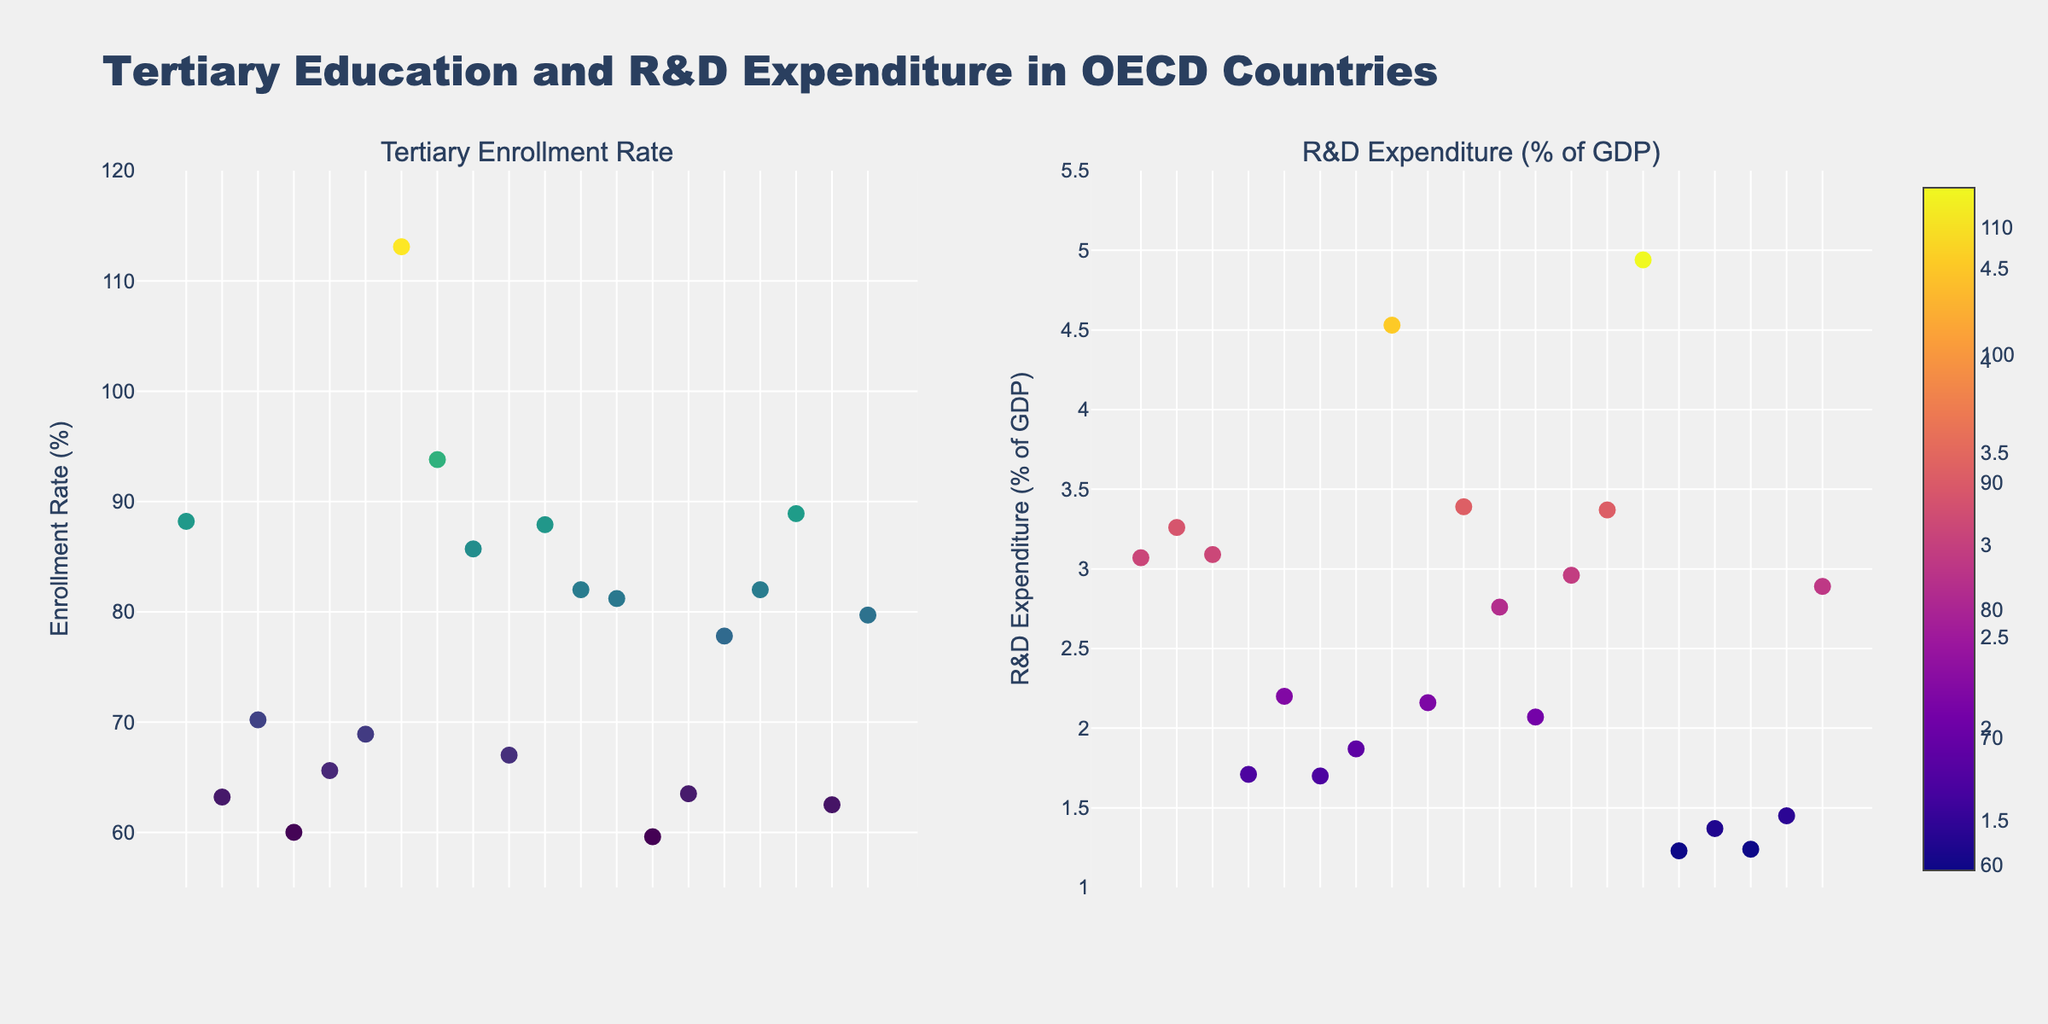What is the title of the figure? The title is generally located at the top of the figure and is usually emphasized with a larger font size. The title here is "Sports Equipment Sales Trends".
Answer: Sports Equipment Sales Trends How many different sports categories are included in the figure? By looking at the subplot titles, we can see there are four different sports categories.
Answer: Four Which sports category has the highest sales volume for high-priced items? By examining the "High" price range bubbles across the different subplots, the soccer category has the highest sales volume with a figure of 18,000 for Adidas.
Answer: Soccer What is the market share size of the Nike medium-priced basketball category? The market share of Nike medium-priced basketball is depicted by the size of the bubble in the basketball subplot, where larger bubbles indicate a higher market share. The information for Nike medium-priced basketball is 0.20.
Answer: 0.20 Which brand has the smallest market share in the Tennis category? By comparing the sizes of the bubbles in the Tennis subplot, the smallest bubble belongs to Babolat in the low-price range, with a market share of 0.11.
Answer: Babolat Compare the sales volumes of Nike in medium-priced basketball and medium-priced soccer. Which one is higher? In the 'Basketball' subplot, the medium-priced Nike product has a sales volume of 12,000. In the 'Soccer' subplot, the medium-priced Nike product has a sales volume of 14,000. Therefore, the medium-priced Nike soccer products have a higher sales volume.
Answer: Soccer (14,000) How does the sales volume of high-priced Callaway golf equipment compare to high-priced Wilson tennis equipment? The 'Golf' subplot shows Callaway high-priced items at 7,000 sales volume, while the 'Tennis' subplot shows Wilson high-priced items at 10,000 sales volume. Hence, Wilson's high-priced tennis equipment has a higher sales volume.
Answer: Wilson, higher What is the total market share of the brands in the basketball category? Summing the market shares from the basketball subplot: 0.25 (Nike High) + 0.20 (Adidas Medium) + 0.13 (Spalding Low) equals a total market share of 0.58.
Answer: 0.58 Which brand in the soccer category has the lowest sales volume? In the soccer subplot, the lowest sales volume is represented by the smallest bubble, which belongs to Puma in the low-price range with a figure of 9,000.
Answer: Puma Is the market share of medium-priced TaylorMade golf equipment greater or less than low-priced Titleist golf equipment? By comparing the bubble sizes in the golf subplot, the medium-priced TaylorMade has a market share of 0.10, while the low-priced Titleist has a market share of 0.08. So, TaylorMade's market share is greater.
Answer: Greater 